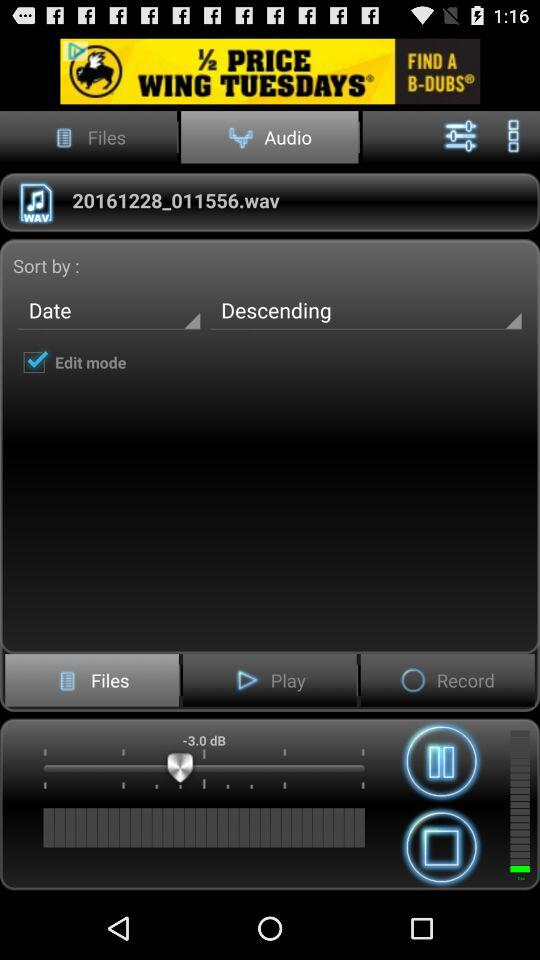What is the status of "Edit mode"? The status is "on". 